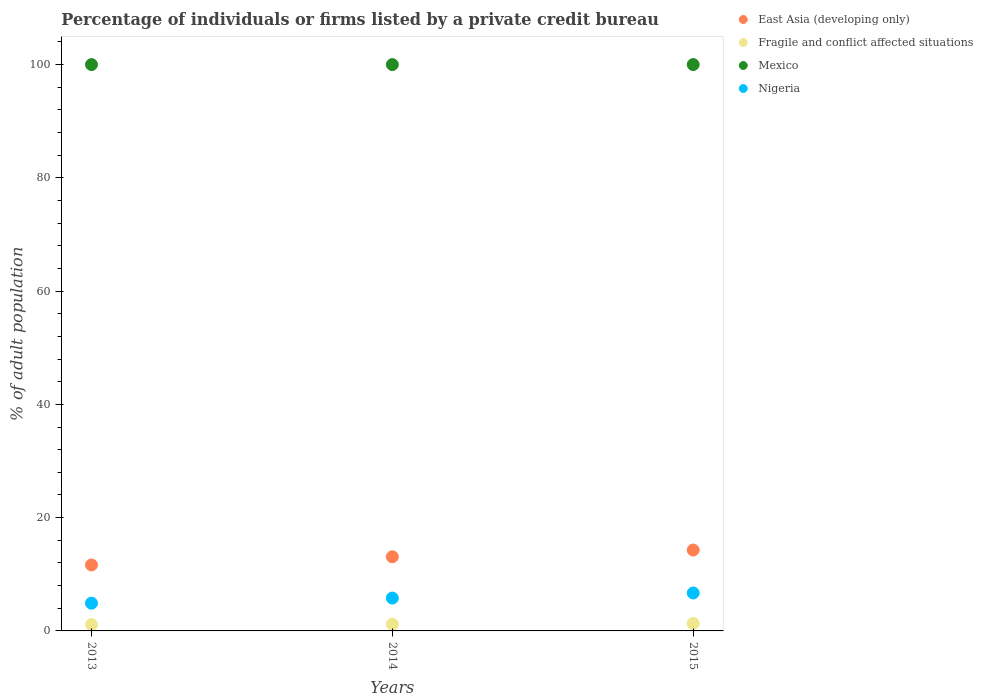Is the number of dotlines equal to the number of legend labels?
Provide a succinct answer. Yes. What is the percentage of population listed by a private credit bureau in Fragile and conflict affected situations in 2013?
Make the answer very short. 1.12. Across all years, what is the maximum percentage of population listed by a private credit bureau in East Asia (developing only)?
Your answer should be compact. 14.28. In which year was the percentage of population listed by a private credit bureau in Nigeria maximum?
Keep it short and to the point. 2015. What is the total percentage of population listed by a private credit bureau in Nigeria in the graph?
Give a very brief answer. 17.4. What is the difference between the percentage of population listed by a private credit bureau in Nigeria in 2013 and that in 2014?
Make the answer very short. -0.9. What is the difference between the percentage of population listed by a private credit bureau in Mexico in 2015 and the percentage of population listed by a private credit bureau in East Asia (developing only) in 2014?
Provide a short and direct response. 86.91. In the year 2013, what is the difference between the percentage of population listed by a private credit bureau in East Asia (developing only) and percentage of population listed by a private credit bureau in Fragile and conflict affected situations?
Provide a succinct answer. 10.52. What is the ratio of the percentage of population listed by a private credit bureau in East Asia (developing only) in 2013 to that in 2015?
Your answer should be very brief. 0.82. Is the percentage of population listed by a private credit bureau in Mexico in 2013 less than that in 2014?
Offer a very short reply. No. In how many years, is the percentage of population listed by a private credit bureau in Mexico greater than the average percentage of population listed by a private credit bureau in Mexico taken over all years?
Offer a very short reply. 0. Is the sum of the percentage of population listed by a private credit bureau in Nigeria in 2014 and 2015 greater than the maximum percentage of population listed by a private credit bureau in Mexico across all years?
Your answer should be very brief. No. Is it the case that in every year, the sum of the percentage of population listed by a private credit bureau in Fragile and conflict affected situations and percentage of population listed by a private credit bureau in East Asia (developing only)  is greater than the sum of percentage of population listed by a private credit bureau in Mexico and percentage of population listed by a private credit bureau in Nigeria?
Make the answer very short. Yes. Is it the case that in every year, the sum of the percentage of population listed by a private credit bureau in Fragile and conflict affected situations and percentage of population listed by a private credit bureau in East Asia (developing only)  is greater than the percentage of population listed by a private credit bureau in Mexico?
Your answer should be very brief. No. Does the percentage of population listed by a private credit bureau in East Asia (developing only) monotonically increase over the years?
Provide a short and direct response. Yes. Is the percentage of population listed by a private credit bureau in Mexico strictly less than the percentage of population listed by a private credit bureau in East Asia (developing only) over the years?
Your answer should be very brief. No. How many years are there in the graph?
Give a very brief answer. 3. Does the graph contain any zero values?
Your response must be concise. No. How are the legend labels stacked?
Offer a terse response. Vertical. What is the title of the graph?
Provide a short and direct response. Percentage of individuals or firms listed by a private credit bureau. Does "Malawi" appear as one of the legend labels in the graph?
Your answer should be compact. No. What is the label or title of the X-axis?
Give a very brief answer. Years. What is the label or title of the Y-axis?
Your answer should be compact. % of adult population. What is the % of adult population of East Asia (developing only) in 2013?
Your response must be concise. 11.64. What is the % of adult population of Fragile and conflict affected situations in 2013?
Ensure brevity in your answer.  1.12. What is the % of adult population in Nigeria in 2013?
Offer a terse response. 4.9. What is the % of adult population of East Asia (developing only) in 2014?
Provide a succinct answer. 13.09. What is the % of adult population of Fragile and conflict affected situations in 2014?
Provide a succinct answer. 1.18. What is the % of adult population in Nigeria in 2014?
Give a very brief answer. 5.8. What is the % of adult population of East Asia (developing only) in 2015?
Give a very brief answer. 14.28. What is the % of adult population of Fragile and conflict affected situations in 2015?
Provide a short and direct response. 1.32. What is the % of adult population of Mexico in 2015?
Provide a succinct answer. 100. Across all years, what is the maximum % of adult population of East Asia (developing only)?
Make the answer very short. 14.28. Across all years, what is the maximum % of adult population in Fragile and conflict affected situations?
Give a very brief answer. 1.32. Across all years, what is the maximum % of adult population in Nigeria?
Provide a succinct answer. 6.7. Across all years, what is the minimum % of adult population in East Asia (developing only)?
Offer a terse response. 11.64. Across all years, what is the minimum % of adult population of Fragile and conflict affected situations?
Provide a short and direct response. 1.12. What is the total % of adult population in East Asia (developing only) in the graph?
Keep it short and to the point. 39.01. What is the total % of adult population of Fragile and conflict affected situations in the graph?
Your answer should be very brief. 3.62. What is the total % of adult population of Mexico in the graph?
Make the answer very short. 300. What is the difference between the % of adult population in East Asia (developing only) in 2013 and that in 2014?
Your answer should be very brief. -1.45. What is the difference between the % of adult population of Fragile and conflict affected situations in 2013 and that in 2014?
Provide a short and direct response. -0.07. What is the difference between the % of adult population of Nigeria in 2013 and that in 2014?
Make the answer very short. -0.9. What is the difference between the % of adult population of East Asia (developing only) in 2013 and that in 2015?
Your answer should be very brief. -2.64. What is the difference between the % of adult population of Fragile and conflict affected situations in 2013 and that in 2015?
Your answer should be very brief. -0.2. What is the difference between the % of adult population of Mexico in 2013 and that in 2015?
Provide a succinct answer. 0. What is the difference between the % of adult population of Nigeria in 2013 and that in 2015?
Offer a terse response. -1.8. What is the difference between the % of adult population of East Asia (developing only) in 2014 and that in 2015?
Keep it short and to the point. -1.19. What is the difference between the % of adult population of Fragile and conflict affected situations in 2014 and that in 2015?
Offer a terse response. -0.13. What is the difference between the % of adult population in Mexico in 2014 and that in 2015?
Make the answer very short. 0. What is the difference between the % of adult population of East Asia (developing only) in 2013 and the % of adult population of Fragile and conflict affected situations in 2014?
Give a very brief answer. 10.46. What is the difference between the % of adult population of East Asia (developing only) in 2013 and the % of adult population of Mexico in 2014?
Your answer should be compact. -88.36. What is the difference between the % of adult population in East Asia (developing only) in 2013 and the % of adult population in Nigeria in 2014?
Your response must be concise. 5.84. What is the difference between the % of adult population in Fragile and conflict affected situations in 2013 and the % of adult population in Mexico in 2014?
Provide a short and direct response. -98.88. What is the difference between the % of adult population of Fragile and conflict affected situations in 2013 and the % of adult population of Nigeria in 2014?
Your response must be concise. -4.68. What is the difference between the % of adult population of Mexico in 2013 and the % of adult population of Nigeria in 2014?
Offer a very short reply. 94.2. What is the difference between the % of adult population in East Asia (developing only) in 2013 and the % of adult population in Fragile and conflict affected situations in 2015?
Offer a terse response. 10.32. What is the difference between the % of adult population in East Asia (developing only) in 2013 and the % of adult population in Mexico in 2015?
Keep it short and to the point. -88.36. What is the difference between the % of adult population of East Asia (developing only) in 2013 and the % of adult population of Nigeria in 2015?
Ensure brevity in your answer.  4.94. What is the difference between the % of adult population in Fragile and conflict affected situations in 2013 and the % of adult population in Mexico in 2015?
Provide a succinct answer. -98.88. What is the difference between the % of adult population of Fragile and conflict affected situations in 2013 and the % of adult population of Nigeria in 2015?
Your response must be concise. -5.58. What is the difference between the % of adult population in Mexico in 2013 and the % of adult population in Nigeria in 2015?
Give a very brief answer. 93.3. What is the difference between the % of adult population in East Asia (developing only) in 2014 and the % of adult population in Fragile and conflict affected situations in 2015?
Provide a short and direct response. 11.77. What is the difference between the % of adult population of East Asia (developing only) in 2014 and the % of adult population of Mexico in 2015?
Your answer should be compact. -86.91. What is the difference between the % of adult population in East Asia (developing only) in 2014 and the % of adult population in Nigeria in 2015?
Provide a short and direct response. 6.39. What is the difference between the % of adult population of Fragile and conflict affected situations in 2014 and the % of adult population of Mexico in 2015?
Offer a terse response. -98.82. What is the difference between the % of adult population in Fragile and conflict affected situations in 2014 and the % of adult population in Nigeria in 2015?
Your answer should be very brief. -5.52. What is the difference between the % of adult population in Mexico in 2014 and the % of adult population in Nigeria in 2015?
Provide a short and direct response. 93.3. What is the average % of adult population in East Asia (developing only) per year?
Provide a short and direct response. 13. What is the average % of adult population in Fragile and conflict affected situations per year?
Offer a very short reply. 1.21. In the year 2013, what is the difference between the % of adult population of East Asia (developing only) and % of adult population of Fragile and conflict affected situations?
Give a very brief answer. 10.52. In the year 2013, what is the difference between the % of adult population of East Asia (developing only) and % of adult population of Mexico?
Make the answer very short. -88.36. In the year 2013, what is the difference between the % of adult population of East Asia (developing only) and % of adult population of Nigeria?
Offer a terse response. 6.74. In the year 2013, what is the difference between the % of adult population in Fragile and conflict affected situations and % of adult population in Mexico?
Your response must be concise. -98.88. In the year 2013, what is the difference between the % of adult population in Fragile and conflict affected situations and % of adult population in Nigeria?
Your answer should be compact. -3.78. In the year 2013, what is the difference between the % of adult population of Mexico and % of adult population of Nigeria?
Your answer should be compact. 95.1. In the year 2014, what is the difference between the % of adult population of East Asia (developing only) and % of adult population of Fragile and conflict affected situations?
Offer a terse response. 11.91. In the year 2014, what is the difference between the % of adult population in East Asia (developing only) and % of adult population in Mexico?
Keep it short and to the point. -86.91. In the year 2014, what is the difference between the % of adult population of East Asia (developing only) and % of adult population of Nigeria?
Ensure brevity in your answer.  7.29. In the year 2014, what is the difference between the % of adult population in Fragile and conflict affected situations and % of adult population in Mexico?
Your answer should be very brief. -98.82. In the year 2014, what is the difference between the % of adult population of Fragile and conflict affected situations and % of adult population of Nigeria?
Your answer should be very brief. -4.62. In the year 2014, what is the difference between the % of adult population in Mexico and % of adult population in Nigeria?
Your answer should be very brief. 94.2. In the year 2015, what is the difference between the % of adult population of East Asia (developing only) and % of adult population of Fragile and conflict affected situations?
Ensure brevity in your answer.  12.96. In the year 2015, what is the difference between the % of adult population of East Asia (developing only) and % of adult population of Mexico?
Your answer should be compact. -85.72. In the year 2015, what is the difference between the % of adult population in East Asia (developing only) and % of adult population in Nigeria?
Your response must be concise. 7.58. In the year 2015, what is the difference between the % of adult population in Fragile and conflict affected situations and % of adult population in Mexico?
Keep it short and to the point. -98.68. In the year 2015, what is the difference between the % of adult population in Fragile and conflict affected situations and % of adult population in Nigeria?
Ensure brevity in your answer.  -5.38. In the year 2015, what is the difference between the % of adult population in Mexico and % of adult population in Nigeria?
Provide a short and direct response. 93.3. What is the ratio of the % of adult population of East Asia (developing only) in 2013 to that in 2014?
Your answer should be very brief. 0.89. What is the ratio of the % of adult population in Fragile and conflict affected situations in 2013 to that in 2014?
Your response must be concise. 0.94. What is the ratio of the % of adult population of Nigeria in 2013 to that in 2014?
Provide a short and direct response. 0.84. What is the ratio of the % of adult population of East Asia (developing only) in 2013 to that in 2015?
Provide a short and direct response. 0.82. What is the ratio of the % of adult population of Fragile and conflict affected situations in 2013 to that in 2015?
Offer a very short reply. 0.85. What is the ratio of the % of adult population in Nigeria in 2013 to that in 2015?
Provide a short and direct response. 0.73. What is the ratio of the % of adult population of East Asia (developing only) in 2014 to that in 2015?
Give a very brief answer. 0.92. What is the ratio of the % of adult population of Fragile and conflict affected situations in 2014 to that in 2015?
Your answer should be very brief. 0.9. What is the ratio of the % of adult population in Nigeria in 2014 to that in 2015?
Keep it short and to the point. 0.87. What is the difference between the highest and the second highest % of adult population of East Asia (developing only)?
Make the answer very short. 1.19. What is the difference between the highest and the second highest % of adult population in Fragile and conflict affected situations?
Give a very brief answer. 0.13. What is the difference between the highest and the second highest % of adult population of Nigeria?
Ensure brevity in your answer.  0.9. What is the difference between the highest and the lowest % of adult population of East Asia (developing only)?
Provide a short and direct response. 2.64. What is the difference between the highest and the lowest % of adult population in Mexico?
Make the answer very short. 0. What is the difference between the highest and the lowest % of adult population of Nigeria?
Provide a succinct answer. 1.8. 